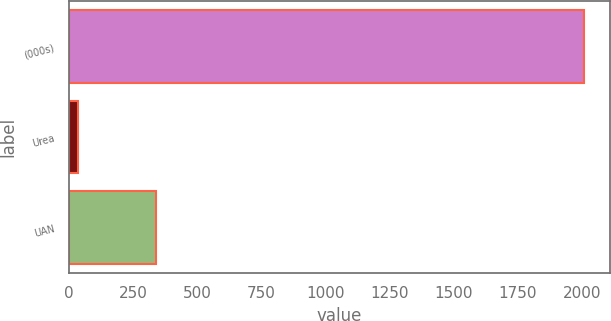Convert chart. <chart><loc_0><loc_0><loc_500><loc_500><bar_chart><fcel>(000s)<fcel>Urea<fcel>UAN<nl><fcel>2009<fcel>36<fcel>339<nl></chart> 